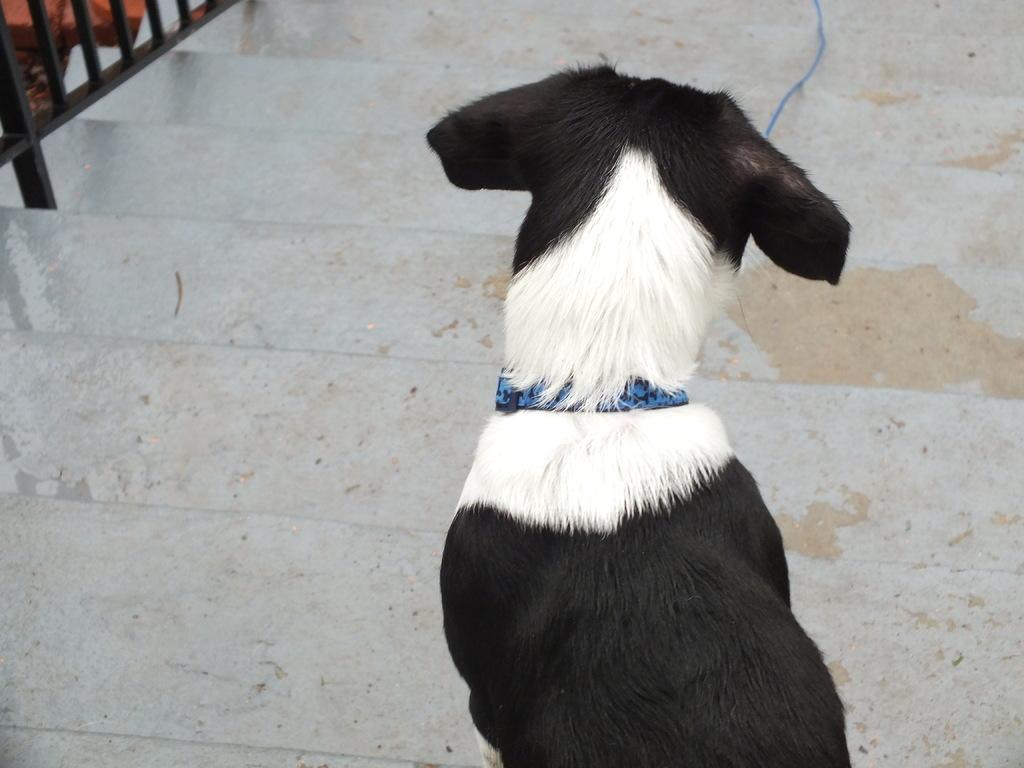What animal is present in the image? There is a dog in the picture. Can you describe the appearance of the dog? The dog is black and white. Where is the dog located in the image? The dog is on the steps. What is attached to the dog's neck? There is a blue chain tied around the dog's neck. What type of cherries is the dog eating in the image? There are no cherries present in the image, and the dog is not eating anything. Can you see the father of the dog in the image? There is no reference to a father or any people in the image, only the dog. Is there a ship visible in the background of the image? There is no ship present in the image; it only features a dog on the steps. 